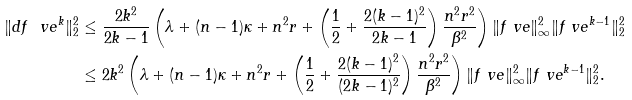<formula> <loc_0><loc_0><loc_500><loc_500>\| d f _ { \ } v e ^ { k } \| _ { 2 } ^ { 2 } & \leq \frac { 2 k ^ { 2 } } { 2 k - 1 } \left ( \lambda + ( n - 1 ) \kappa + n ^ { 2 } r + \left ( \frac { 1 } { 2 } + \frac { 2 ( k - 1 ) ^ { 2 } } { 2 k - 1 } \right ) \frac { n ^ { 2 } r ^ { 2 } } { \beta ^ { 2 } } \right ) \| f _ { \ } v e \| _ { \infty } ^ { 2 } \| f _ { \ } v e ^ { k - 1 } \| _ { 2 } ^ { 2 } \\ & \leq 2 k ^ { 2 } \left ( \lambda + ( n - 1 ) \kappa + n ^ { 2 } r + \left ( \frac { 1 } { 2 } + \frac { 2 ( k - 1 ) ^ { 2 } } { ( 2 k - 1 ) ^ { 2 } } \right ) \frac { n ^ { 2 } r ^ { 2 } } { \beta ^ { 2 } } \right ) \| f _ { \ } v e \| _ { \infty } ^ { 2 } \| f _ { \ } v e ^ { k - 1 } \| _ { 2 } ^ { 2 } .</formula> 